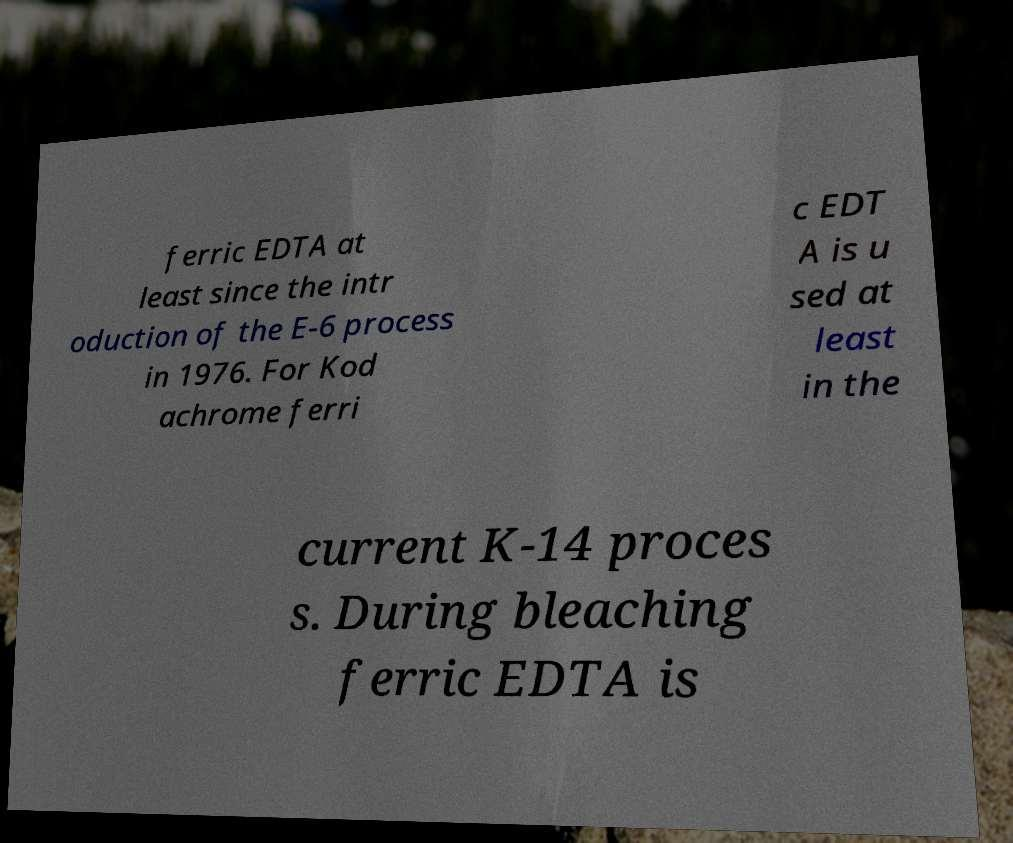What messages or text are displayed in this image? I need them in a readable, typed format. ferric EDTA at least since the intr oduction of the E-6 process in 1976. For Kod achrome ferri c EDT A is u sed at least in the current K-14 proces s. During bleaching ferric EDTA is 